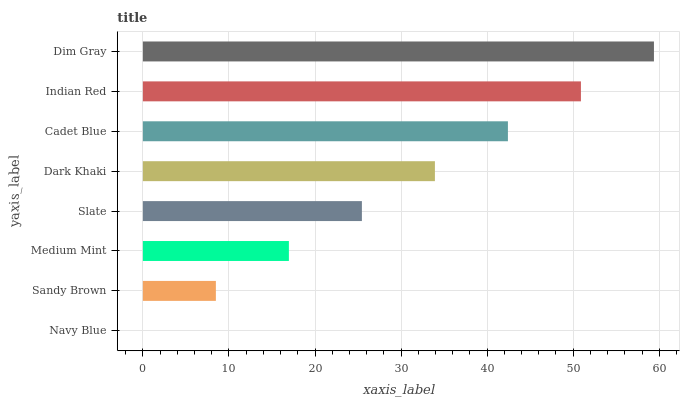Is Navy Blue the minimum?
Answer yes or no. Yes. Is Dim Gray the maximum?
Answer yes or no. Yes. Is Sandy Brown the minimum?
Answer yes or no. No. Is Sandy Brown the maximum?
Answer yes or no. No. Is Sandy Brown greater than Navy Blue?
Answer yes or no. Yes. Is Navy Blue less than Sandy Brown?
Answer yes or no. Yes. Is Navy Blue greater than Sandy Brown?
Answer yes or no. No. Is Sandy Brown less than Navy Blue?
Answer yes or no. No. Is Dark Khaki the high median?
Answer yes or no. Yes. Is Slate the low median?
Answer yes or no. Yes. Is Sandy Brown the high median?
Answer yes or no. No. Is Dim Gray the low median?
Answer yes or no. No. 